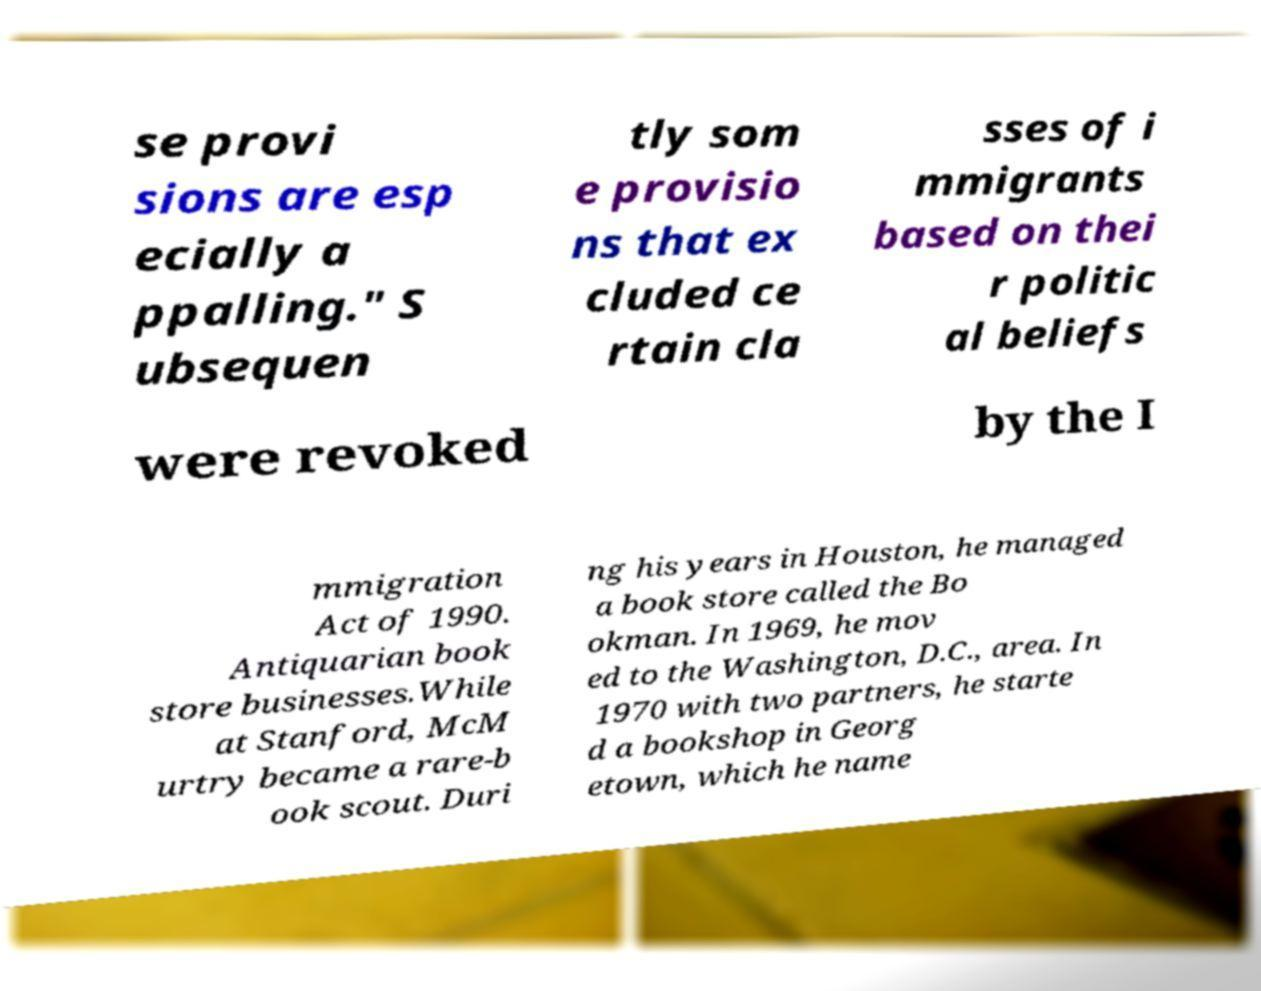Please read and relay the text visible in this image. What does it say? se provi sions are esp ecially a ppalling." S ubsequen tly som e provisio ns that ex cluded ce rtain cla sses of i mmigrants based on thei r politic al beliefs were revoked by the I mmigration Act of 1990. Antiquarian book store businesses.While at Stanford, McM urtry became a rare-b ook scout. Duri ng his years in Houston, he managed a book store called the Bo okman. In 1969, he mov ed to the Washington, D.C., area. In 1970 with two partners, he starte d a bookshop in Georg etown, which he name 